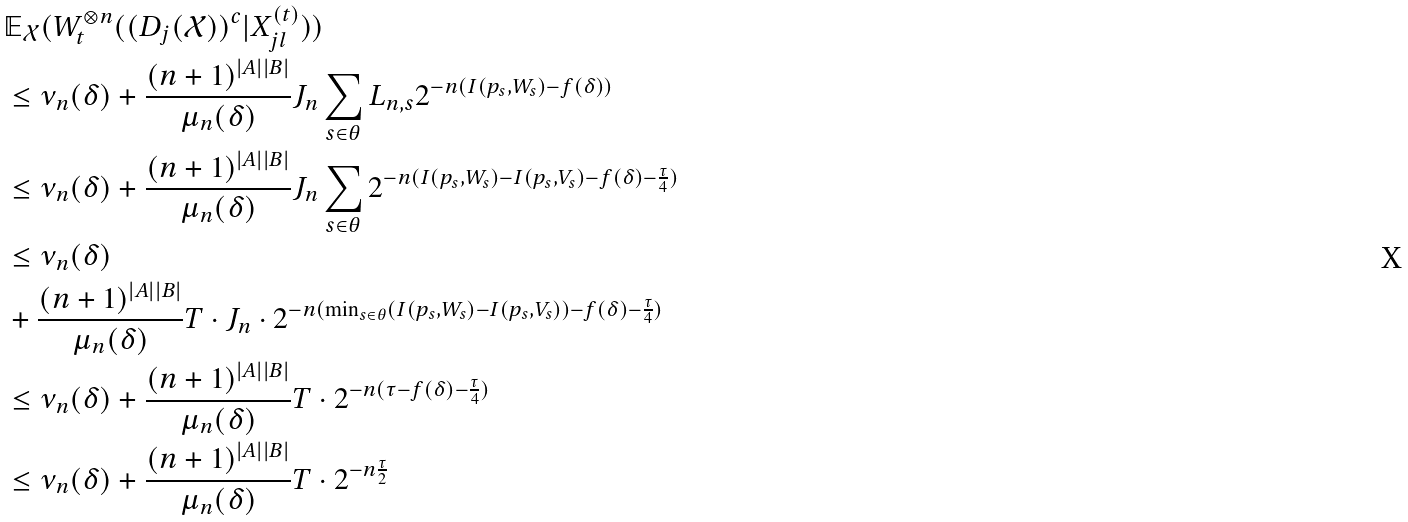<formula> <loc_0><loc_0><loc_500><loc_500>& \mathbb { E } _ { \mathcal { X } } ( W _ { t } ^ { \otimes n } ( ( D _ { j } ( \mathcal { X } ) ) ^ { c } | X _ { j l } ^ { ( t ) } ) ) \\ & \leq \nu _ { n } ( \delta ) + \frac { ( n + 1 ) ^ { | A | | B | } } { \mu _ { n } ( \delta ) } J _ { n } \sum _ { s \in \theta } L _ { n , s } 2 ^ { - n ( I ( p _ { s } , W _ { s } ) - f ( \delta ) ) } \\ & \leq \nu _ { n } ( \delta ) + \frac { ( n + 1 ) ^ { | A | | B | } } { \mu _ { n } ( \delta ) } J _ { n } \sum _ { s \in \theta } 2 ^ { - n ( I ( p _ { s } , W _ { s } ) - I ( p _ { s } , V _ { s } ) - f ( \delta ) - \frac { \tau } { 4 } ) } \\ & \leq \nu _ { n } ( \delta ) \\ & + \frac { ( n + 1 ) ^ { | A | | B | } } { \mu _ { n } ( \delta ) } T \cdot J _ { n } \cdot 2 ^ { - n ( \min _ { s \in \theta } ( I ( p _ { s } , W _ { s } ) - I ( p _ { s } , V _ { s } ) ) - f ( \delta ) - \frac { \tau } { 4 } ) } \\ & \leq \nu _ { n } ( \delta ) + \frac { ( n + 1 ) ^ { | A | | B | } } { \mu _ { n } ( \delta ) } T \cdot 2 ^ { - n ( \tau - f ( \delta ) - \frac { \tau } { 4 } ) } \\ & \leq \nu _ { n } ( \delta ) + \frac { ( n + 1 ) ^ { | A | | B | } } { \mu _ { n } ( \delta ) } T \cdot 2 ^ { - n \frac { \tau } { 2 } }</formula> 